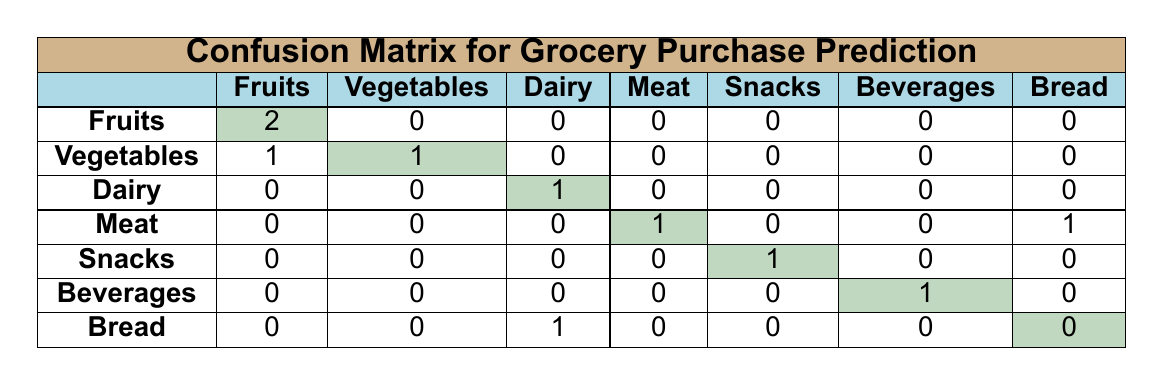What is the total number of correct predictions for Fruits? In the confusion matrix, the value in the row for Fruits and in the column for Fruits is 2. This indicates there were 2 instances where the prediction was correct for Fruits.
Answer: 2 How many times was Vegetables predicted correctly? The confusion matrix shows that in the row for Vegetables, the corresponding column for Vegetables has a value of 1. This indicates there was 1 correct prediction for Vegetables.
Answer: 1 Did any customers mispredict their purchases for Meat? Looking at the row for Meat, the value in the corresponding column for Meat is 1, indicating that there was 1 correct prediction. This means there were no mispredictions specifically for Meat in this table.
Answer: No Which item had the highest number of mispredictions? By examining each column, we can see that Dairy Products has 0 predicted values, Meats has a prediction of 1 for Bread, and others have similar distributions. However, the only mispredictions are shown in the row for Meat (where the prediction was incorrectly predicted as processed food). Therefore, there are 2 mispredictions overall: 1 for Dairy Products and 1 for Meat.
Answer: Meat What is the total number of purchased items predicted as Dairy Products? In the confusion matrix, looking at the Dairy Products row, we can see it was predicted correctly 1 time, with 1 misprediction categorically classified as Dairy Products (actually Bread). Thus, the total can be calculated by simply summing these values, resulting in 2 predictions for Dairy Products.
Answer: 2 How many customers in the age group 25-34 purchased Snacks? In the data, looking at age group 25-34, the only customer was customer 2, who purchased Vegetables, indicating there were no purchases of Snacks from customers in that age group.
Answer: 0 What percentage of purchased items were predicted correctly? The total correct predictions can be counted from the diagonal of the matrix (2 for Fruits, 1 for Vegetables, 1 for Dairy Products, 1 for Meat, 1 for Snacks, and 1 for Beverages), which gives a total of 7 correct predictions. There are 10 total purchases. Therefore, (7/10) * 100 = 70%.
Answer: 70% Was there any instance of a customer buying Snacks but being predicted to buy a different item? In the row for Snacks, we see that it shows 1 correct prediction. Therefore, there were no instances of a customer buying Snacks and being predicted differently.
Answer: No 